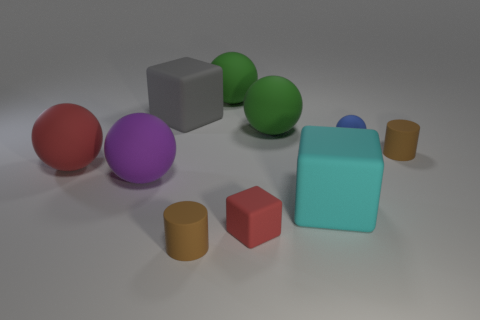Subtract all big cyan blocks. How many blocks are left? 2 Subtract all brown blocks. How many green spheres are left? 2 Subtract all green balls. How many balls are left? 3 Subtract all blocks. How many objects are left? 7 Subtract 1 cubes. How many cubes are left? 2 Add 2 blocks. How many blocks exist? 5 Subtract 0 brown cubes. How many objects are left? 10 Subtract all gray cylinders. Subtract all red balls. How many cylinders are left? 2 Subtract all green matte balls. Subtract all brown rubber cylinders. How many objects are left? 6 Add 1 red blocks. How many red blocks are left? 2 